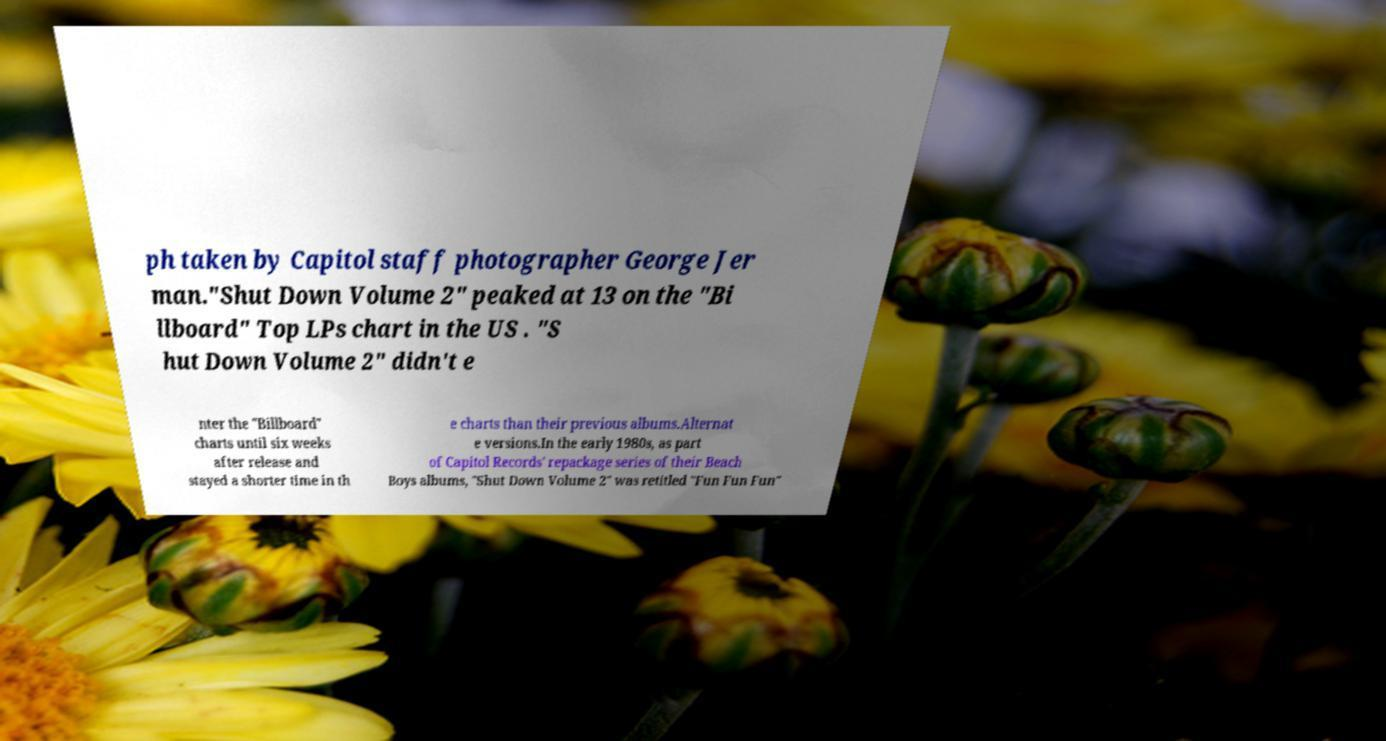What messages or text are displayed in this image? I need them in a readable, typed format. ph taken by Capitol staff photographer George Jer man."Shut Down Volume 2" peaked at 13 on the "Bi llboard" Top LPs chart in the US . "S hut Down Volume 2" didn't e nter the "Billboard" charts until six weeks after release and stayed a shorter time in th e charts than their previous albums.Alternat e versions.In the early 1980s, as part of Capitol Records' repackage series of their Beach Boys albums, "Shut Down Volume 2" was retitled "Fun Fun Fun" 